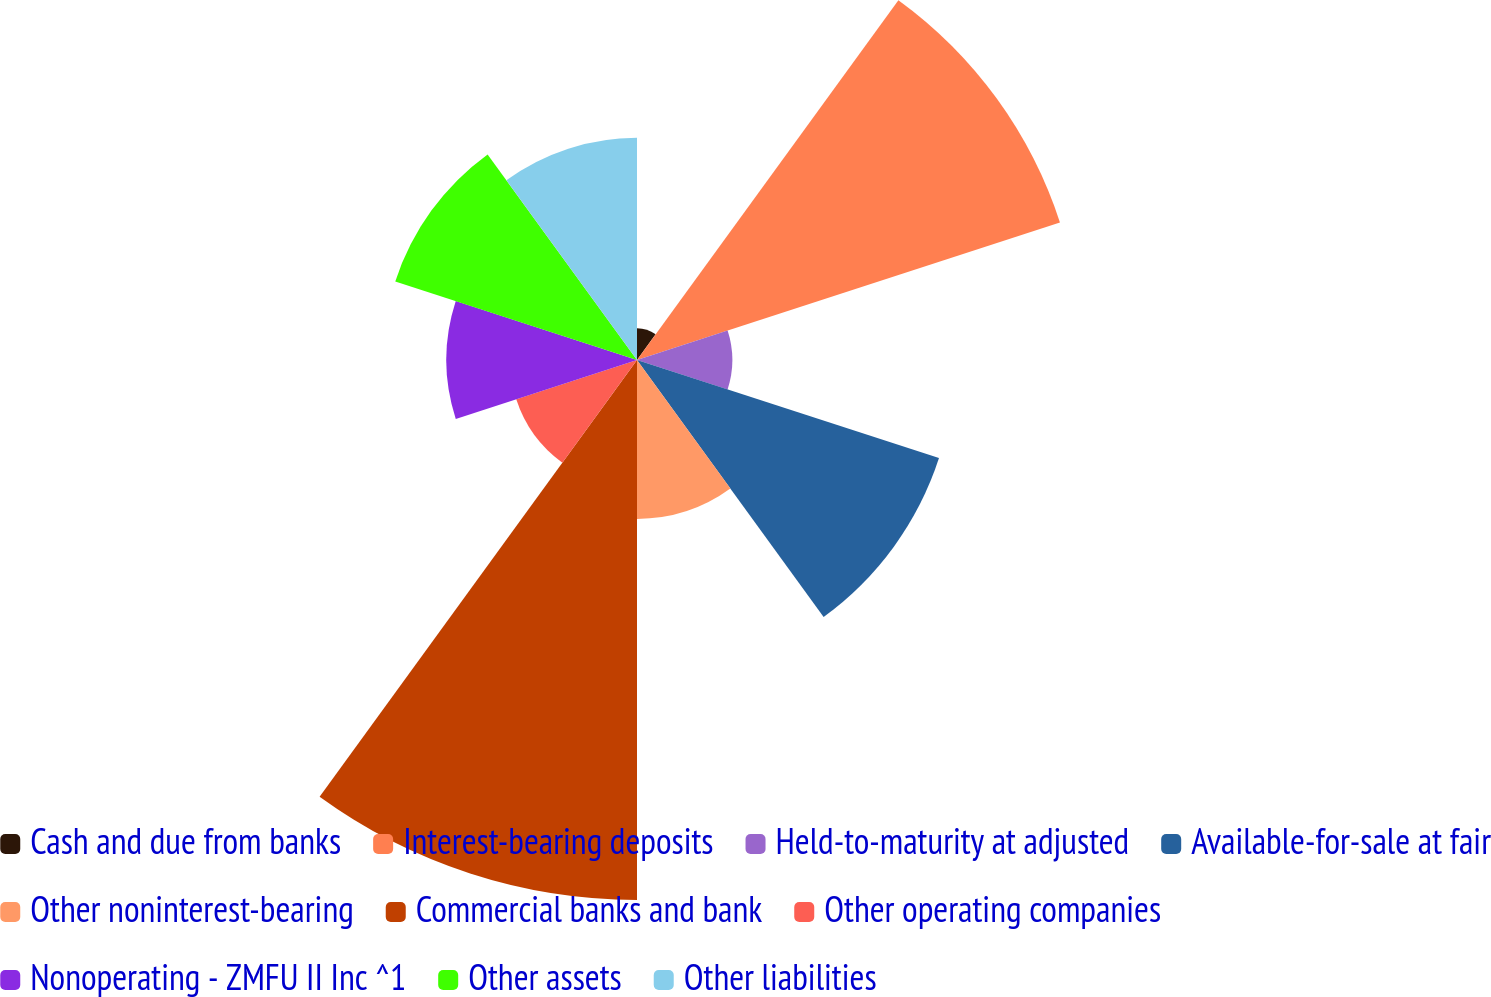<chart> <loc_0><loc_0><loc_500><loc_500><pie_chart><fcel>Cash and due from banks<fcel>Interest-bearing deposits<fcel>Held-to-maturity at adjusted<fcel>Available-for-sale at fair<fcel>Other noninterest-bearing<fcel>Commercial banks and bank<fcel>Other operating companies<fcel>Nonoperating - ZMFU II Inc ^1<fcel>Other assets<fcel>Other liabilities<nl><fcel>1.33%<fcel>18.67%<fcel>4.0%<fcel>13.33%<fcel>6.67%<fcel>22.67%<fcel>5.33%<fcel>8.0%<fcel>10.67%<fcel>9.33%<nl></chart> 